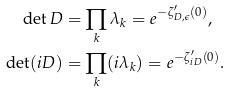<formula> <loc_0><loc_0><loc_500><loc_500>\det D & = \prod _ { k } \lambda _ { k } = e ^ { - \zeta _ { D , \epsilon } ^ { \prime } ( 0 ) } , \\ \det ( i D ) & = \prod _ { k } ( i \lambda _ { k } ) = e ^ { - \zeta _ { i D } ^ { \prime } ( 0 ) } .</formula> 